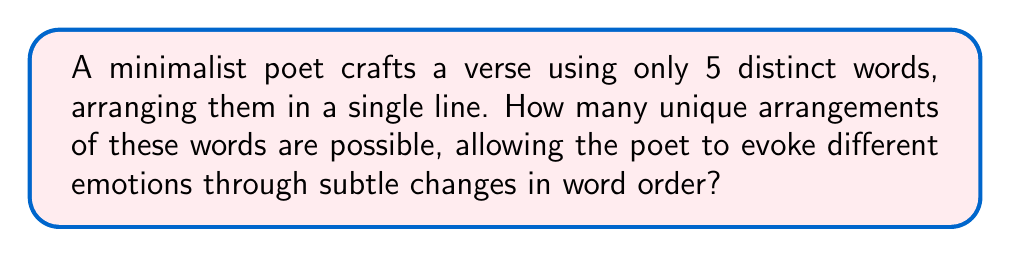Could you help me with this problem? To solve this problem, we need to consider the fundamental principle of permutations. Since we are dealing with 5 distinct words, and each word can be used only once in the arrangement, this is a straightforward permutation problem.

The number of permutations of n distinct objects is given by the factorial of n, denoted as n!

In this case:
n = 5 (number of distinct words)

Therefore, the number of unique arrangements is:

$$5! = 5 \times 4 \times 3 \times 2 \times 1 = 120$$

Step-by-step calculation:
1. Start with 5 choices for the first word
2. For the second word, we have 4 remaining choices
3. For the third word, we have 3 remaining choices
4. For the fourth word, we have 2 remaining choices
5. For the last word, we have only 1 choice left

Multiplying these choices together:
$$5 \times 4 \times 3 \times 2 \times 1 = 120$$

This result represents the total number of ways the poet can arrange the 5 words, each arrangement potentially evoking a different emotional response through its unique order.
Answer: 120 